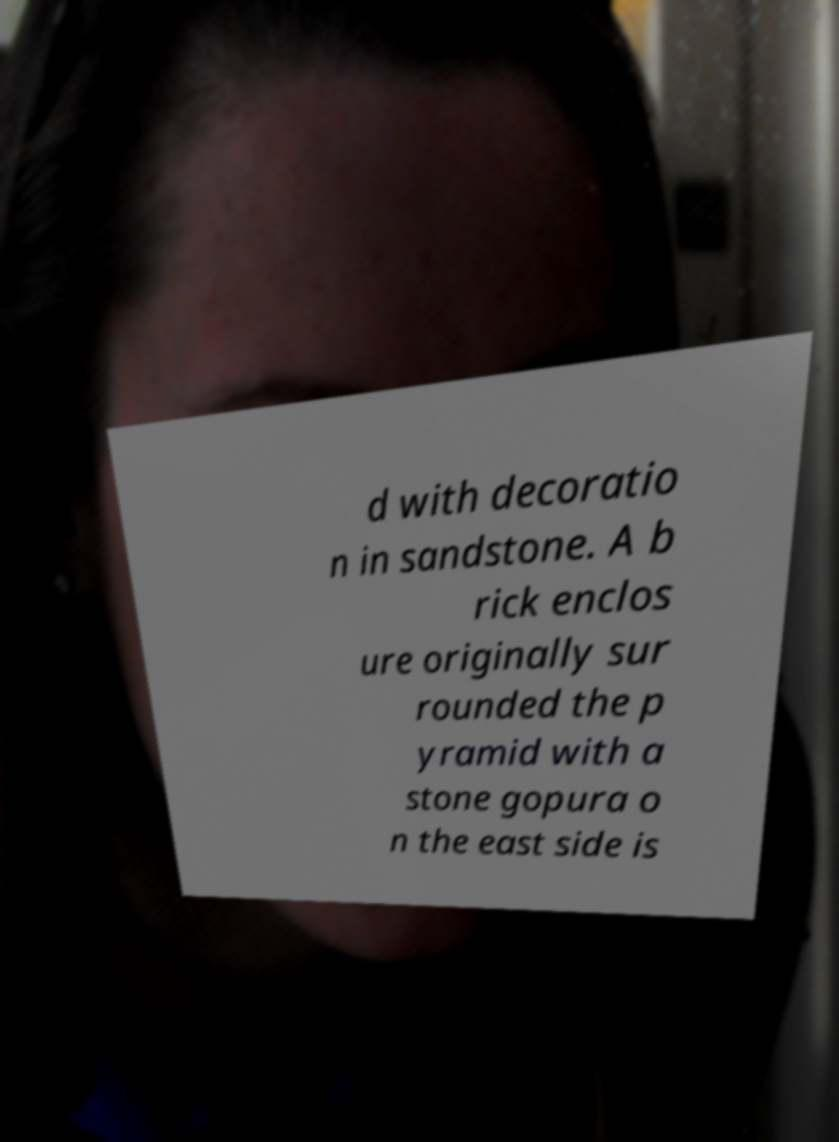Can you accurately transcribe the text from the provided image for me? d with decoratio n in sandstone. A b rick enclos ure originally sur rounded the p yramid with a stone gopura o n the east side is 